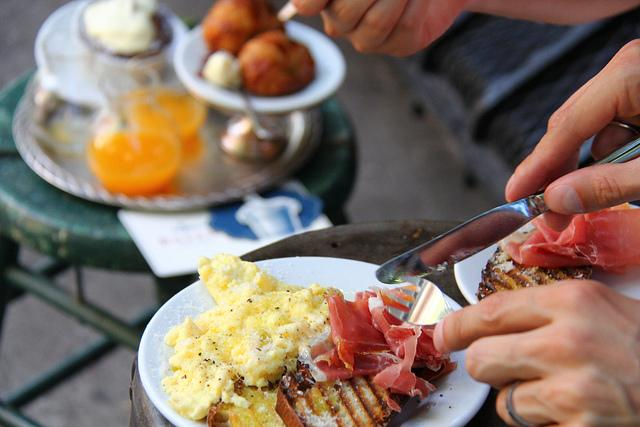What kind of fish is consumed on the side of the breakfast? salmon 